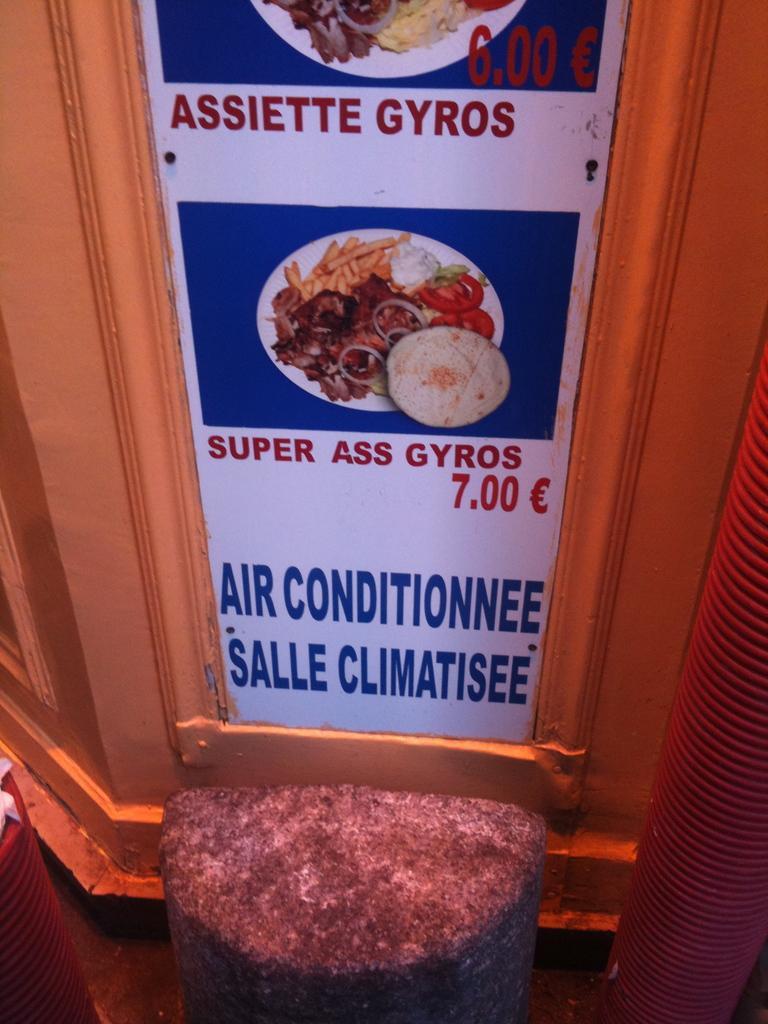How would you summarize this image in a sentence or two? This looks like a menu board, which is attached to the wall. I can see the pictures of the food on the board. This looks like a stool. 